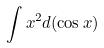<formula> <loc_0><loc_0><loc_500><loc_500>\int x ^ { 2 } d ( \cos x )</formula> 